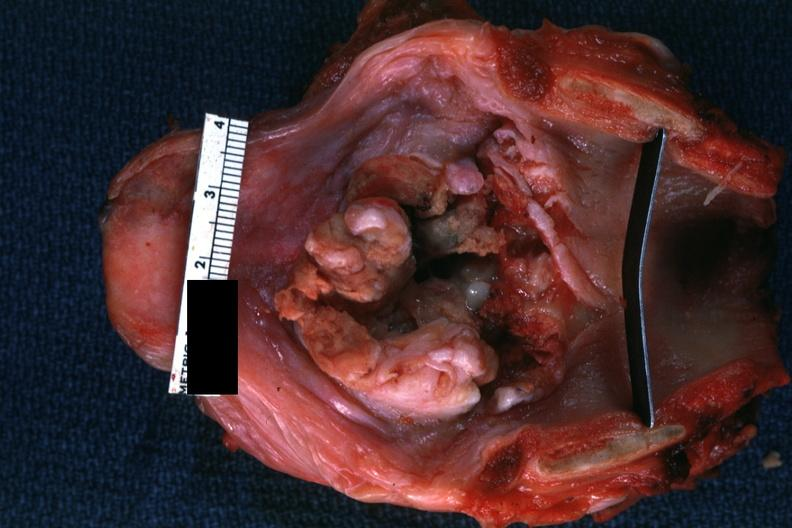s larynx present?
Answer the question using a single word or phrase. Yes 